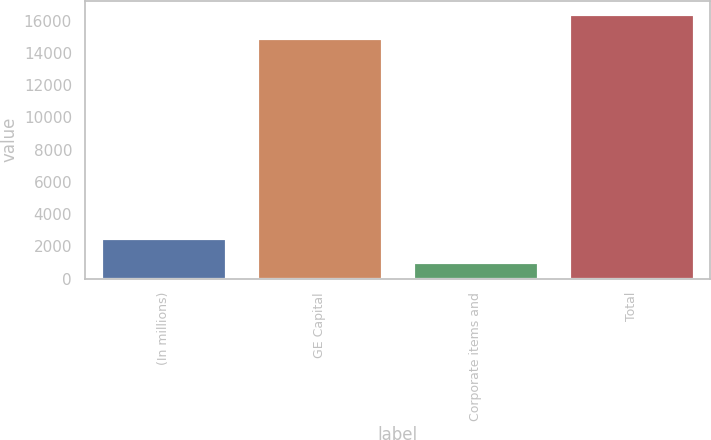Convert chart to OTSL. <chart><loc_0><loc_0><loc_500><loc_500><bar_chart><fcel>(In millions)<fcel>GE Capital<fcel>Corporate items and<fcel>Total<nl><fcel>2551.4<fcel>14924<fcel>1059<fcel>16416.4<nl></chart> 